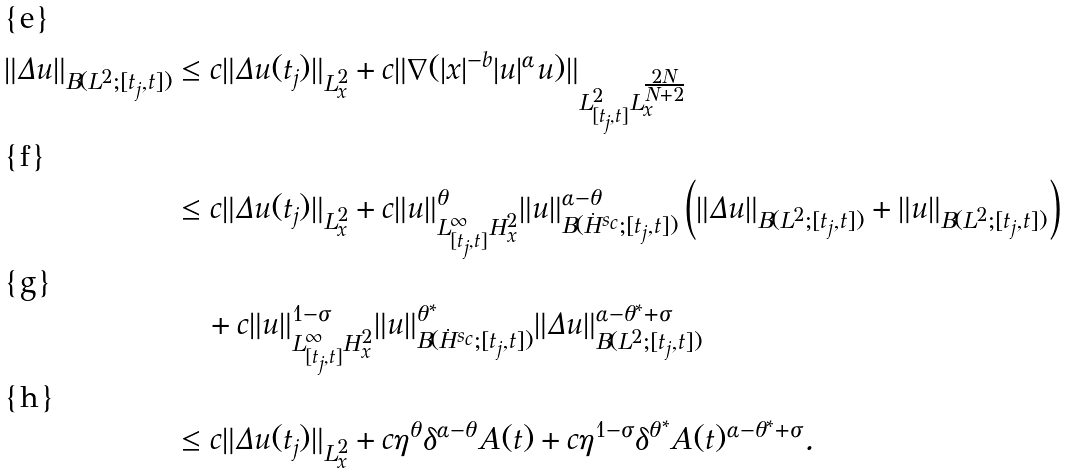<formula> <loc_0><loc_0><loc_500><loc_500>\| \Delta u \| _ { B ( L ^ { 2 } ; [ t _ { j } , t ] ) } & \leq c \| \Delta u ( t _ { j } ) \| _ { L ^ { 2 } _ { x } } + c \| \nabla ( | x | ^ { - b } | u | ^ { \alpha } u ) \| _ { L ^ { 2 } _ { [ t _ { j } , t ] } L _ { x } ^ { \frac { 2 N } { N + 2 } } } \\ & \leq c \| \Delta u ( t _ { j } ) \| _ { L ^ { 2 } _ { x } } + c \| u \| ^ { \theta } _ { L ^ { \infty } _ { [ t _ { j } , t ] } H ^ { 2 } _ { x } } \| u \| ^ { \alpha - \theta } _ { B ( \dot { H } ^ { s _ { c } } ; [ t _ { j } , t ] ) } \left ( \| \Delta u \| _ { B ( L ^ { 2 } ; [ t _ { j } , t ] ) } + \| u \| _ { B ( L ^ { 2 } ; [ t _ { j } , t ] ) } \right ) \\ & \quad + c \| u \| ^ { 1 - \sigma } _ { L _ { [ t _ { j } , t ] } ^ { \infty } H ^ { 2 } _ { x } } \| u \| ^ { \theta ^ { * } } _ { B ( \dot { H } ^ { s _ { c } } ; [ t _ { j } , t ] ) } \| \Delta u \| ^ { \alpha - \theta ^ { * } + \sigma } _ { B ( L ^ { 2 } ; [ t _ { j } , t ] ) } \\ & \leq c \| \Delta u ( t _ { j } ) \| _ { L ^ { 2 } _ { x } } + c \eta ^ { \theta } \delta ^ { \alpha - \theta } A ( t ) + c \eta ^ { 1 - \sigma } \delta ^ { \theta ^ { * } } A ( t ) ^ { \alpha - \theta ^ { * } + \sigma } .</formula> 